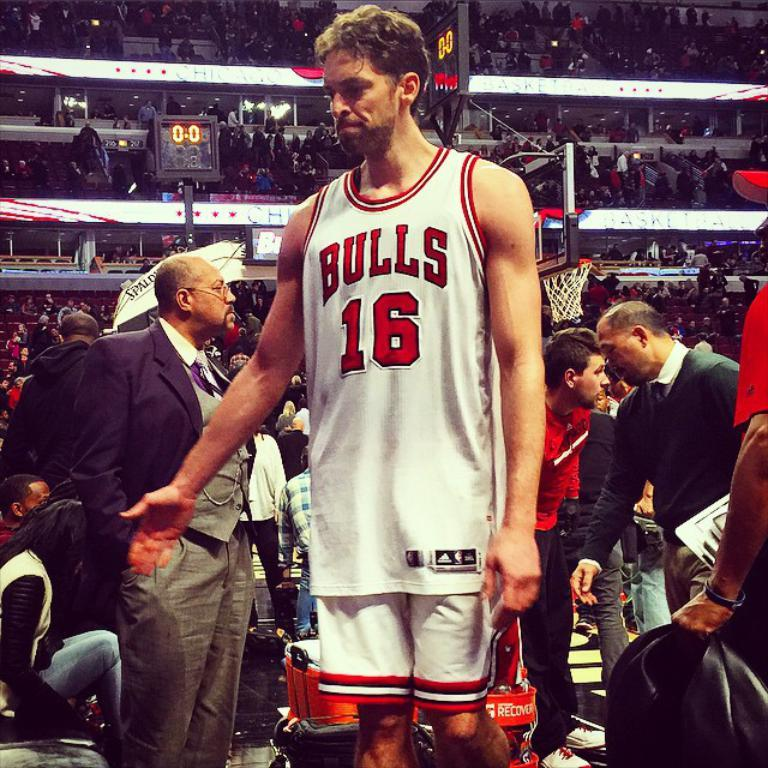<image>
Render a clear and concise summary of the photo. A basketball player with a Chicago bulls logo on his shirt is posing for the picture. 